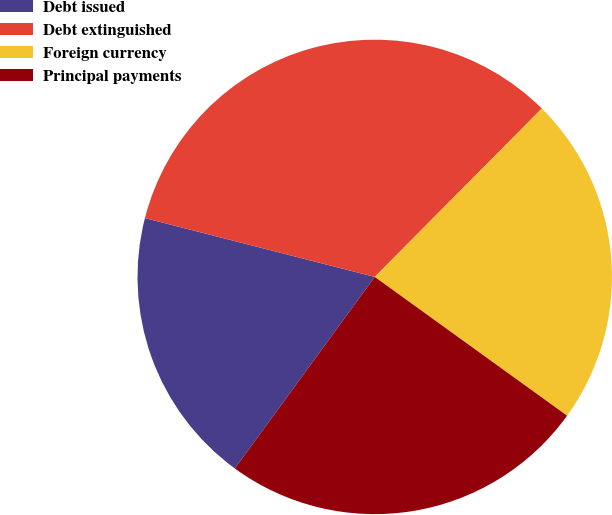Convert chart to OTSL. <chart><loc_0><loc_0><loc_500><loc_500><pie_chart><fcel>Debt issued<fcel>Debt extinguished<fcel>Foreign currency<fcel>Principal payments<nl><fcel>18.95%<fcel>33.45%<fcel>22.51%<fcel>25.09%<nl></chart> 